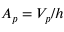Convert formula to latex. <formula><loc_0><loc_0><loc_500><loc_500>A _ { p } = V _ { p } / h</formula> 